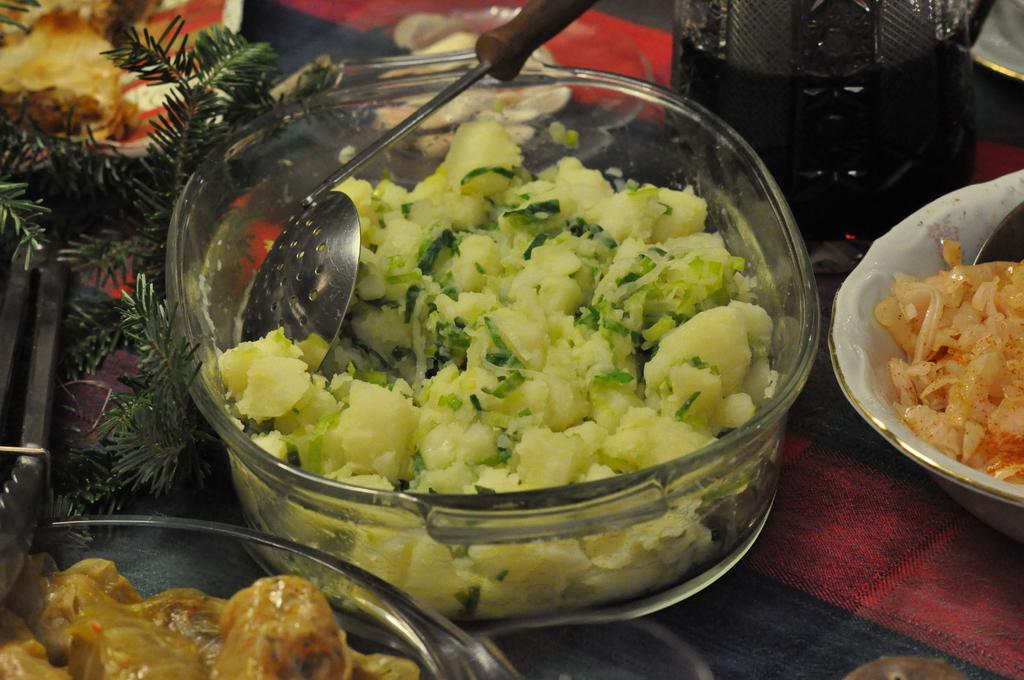What type of containers are present in the image? There are bowls in the image. What is inside the containers? There are food items in the image. What utensil can be seen in the image? There is a spoon in the image. What else is present in the image besides the bowls, food items, and spoon? There are other objects in the image. Where are all these items located? All these items are placed on a platform. Is there a gun visible in the image? No, there is no gun present in the image. Is there any fire or flames visible in the image? No, there is no fire or flames present in the image. 